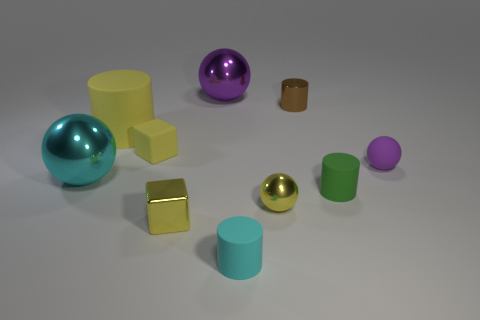Subtract all brown spheres. Subtract all yellow cylinders. How many spheres are left? 4 Subtract all blocks. How many objects are left? 8 Subtract 0 blue cylinders. How many objects are left? 10 Subtract all small yellow matte objects. Subtract all purple shiny balls. How many objects are left? 8 Add 4 yellow things. How many yellow things are left? 8 Add 4 yellow spheres. How many yellow spheres exist? 5 